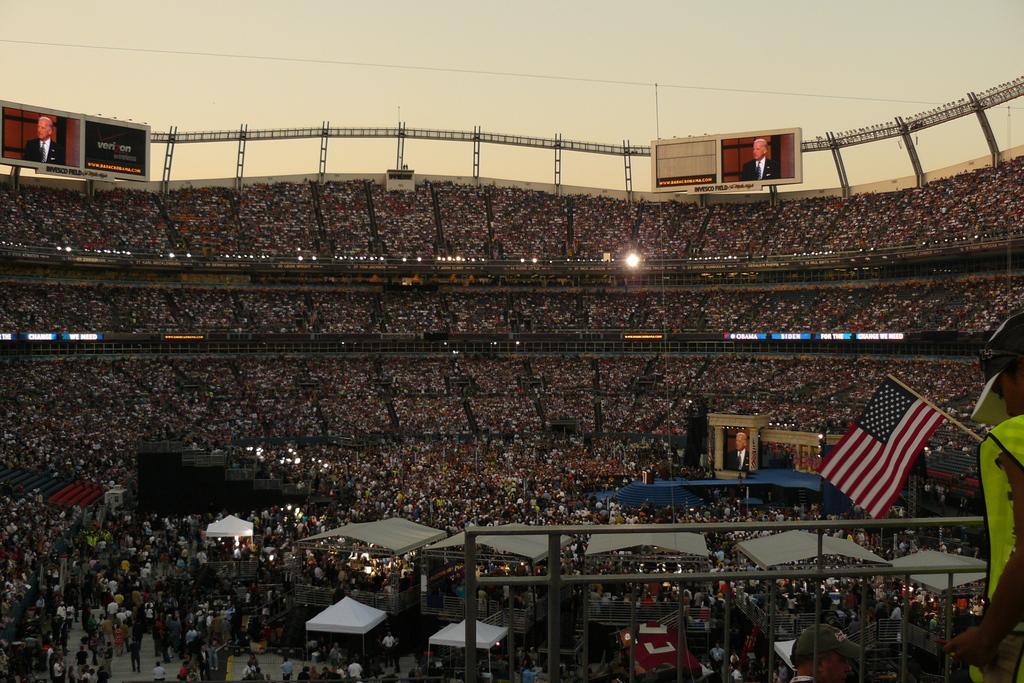Could you give a brief overview of what you see in this image? In this picture we can see a group of people are present in auditorium and also we can see tents, rods, boards, screens, flag, floor. At the top of the image we can see sky, wire, pole. 